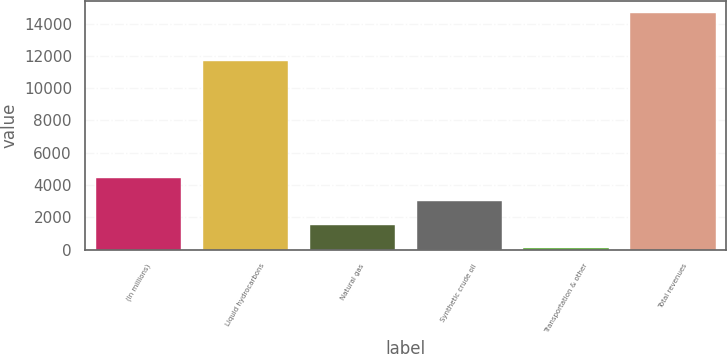Convert chart to OTSL. <chart><loc_0><loc_0><loc_500><loc_500><bar_chart><fcel>(In millions)<fcel>Liquid hydrocarbons<fcel>Natural gas<fcel>Synthetic crude oil<fcel>Transportation & other<fcel>Total revenues<nl><fcel>4450.7<fcel>11717<fcel>1532.9<fcel>2991.8<fcel>74<fcel>14663<nl></chart> 